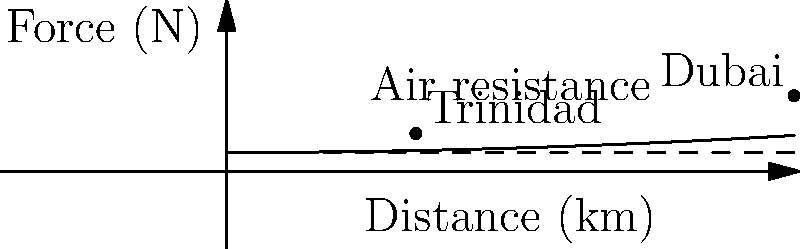A cargo plane is flying from Trinidad to Dubai, covering a distance of 12,000 km. The air resistance force $F$ (in Newtons) acting on the plane can be modeled by the equation $F = 0.0001d^2 + 10$, where $d$ is the distance traveled in kilometers. Calculate the total work done against air resistance during the entire journey. To calculate the work done against air resistance, we need to integrate the force over the distance traveled. Let's break this down step-by-step:

1) The work done is given by the integral of force with respect to distance:

   $W = \int_0^{12000} F(d) \, dd$

2) Substituting the given equation for force:

   $W = \int_0^{12000} (0.0001d^2 + 10) \, dd$

3) Splitting the integral:

   $W = \int_0^{12000} 0.0001d^2 \, dd + \int_0^{12000} 10 \, dd$

4) Integrating each term:

   $W = [0.0001 \cdot \frac{d^3}{3}]_0^{12000} + [10d]_0^{12000}$

5) Evaluating the definite integral:

   $W = (0.0001 \cdot \frac{12000^3}{3} - 0) + (10 \cdot 12000 - 0)$

6) Simplifying:

   $W = 0.0001 \cdot 576,000,000,000 + 120,000$
   $W = 57,600,000 + 120,000$
   $W = 57,720,000$ Joules

Therefore, the total work done against air resistance during the entire journey is 57,720,000 Joules.
Answer: 57,720,000 J 